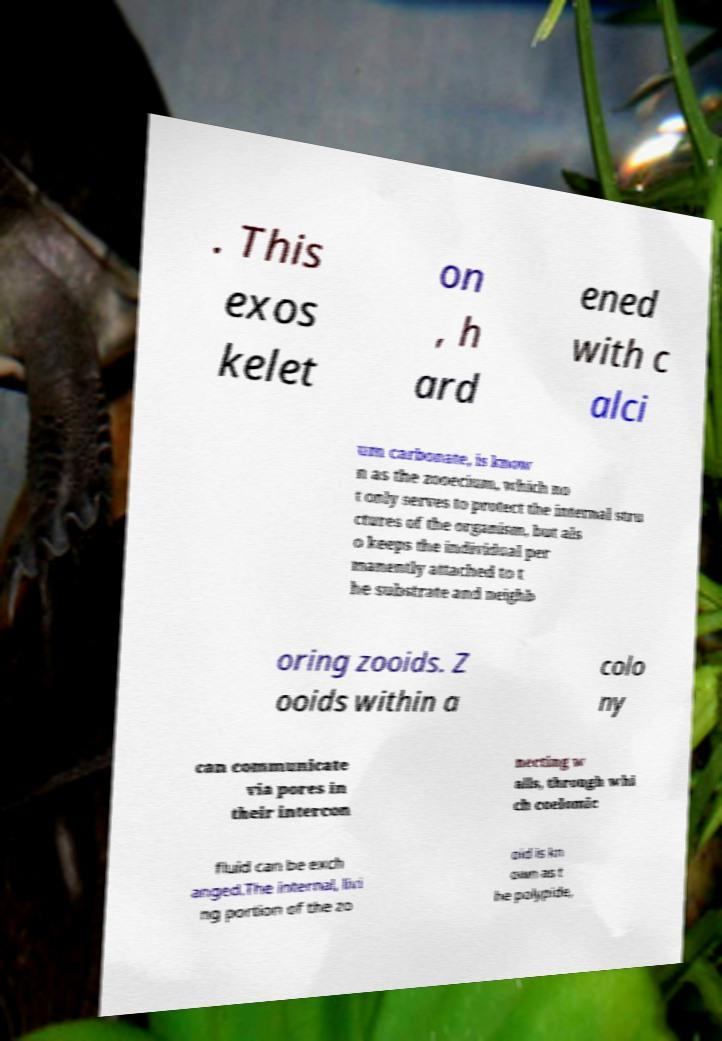Please identify and transcribe the text found in this image. . This exos kelet on , h ard ened with c alci um carbonate, is know n as the zooecium, which no t only serves to protect the internal stru ctures of the organism, but als o keeps the individual per manently attached to t he substrate and neighb oring zooids. Z ooids within a colo ny can communicate via pores in their intercon necting w alls, through whi ch coelomic fluid can be exch anged.The internal, livi ng portion of the zo oid is kn own as t he polypide, 